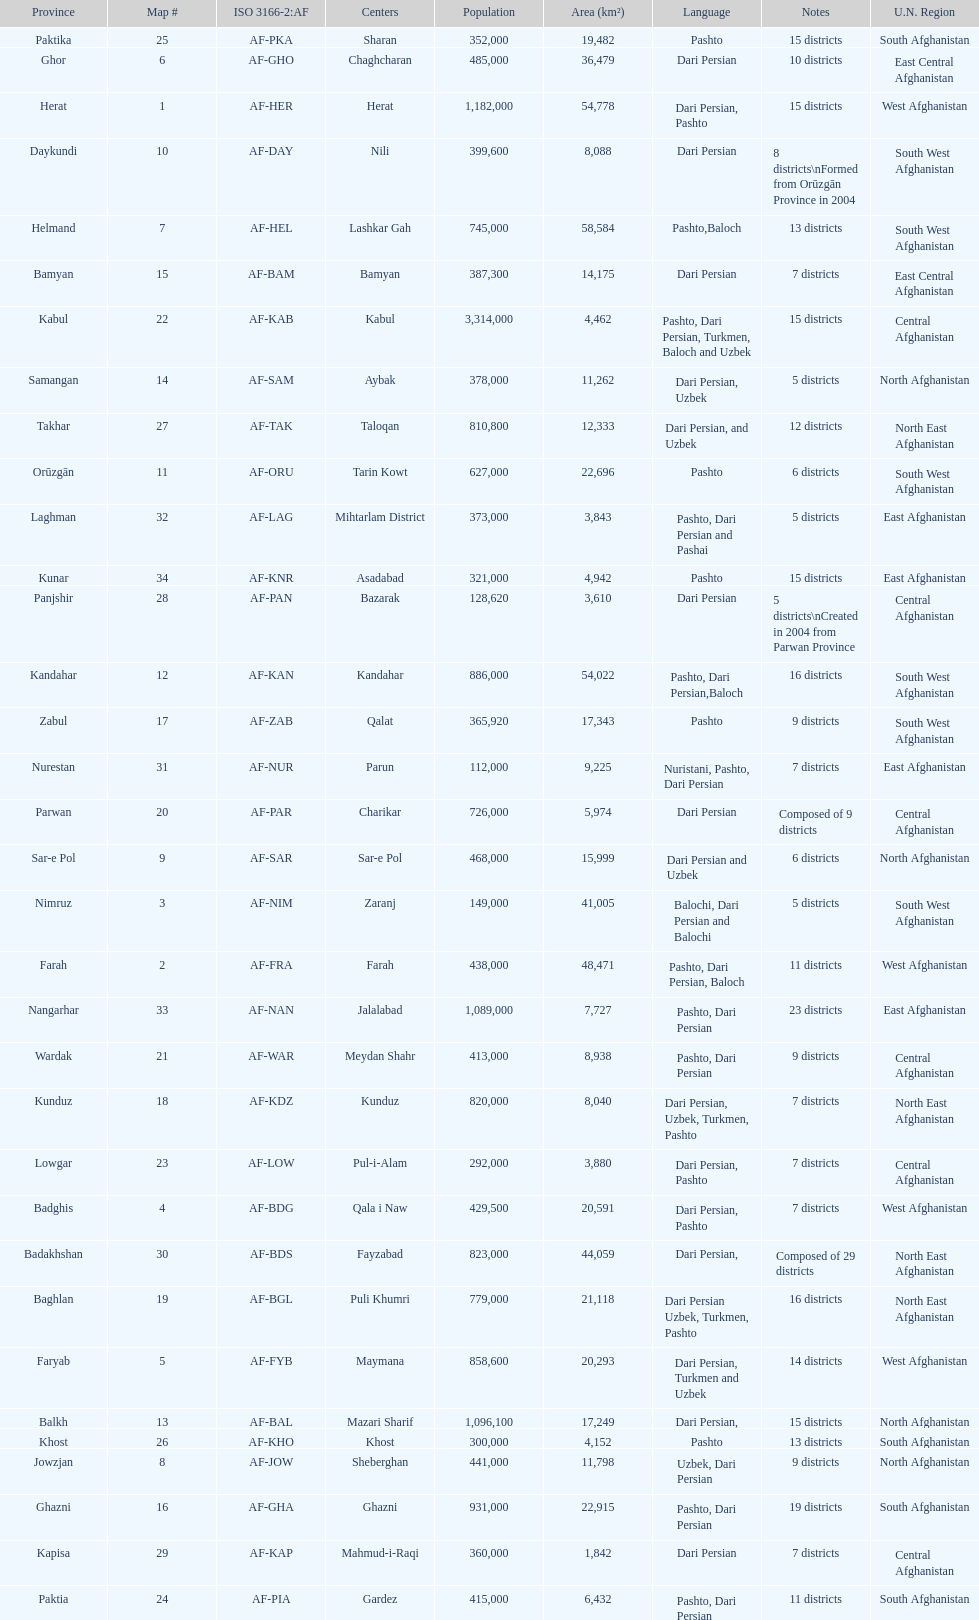Which province has the most districts? Badakhshan. 